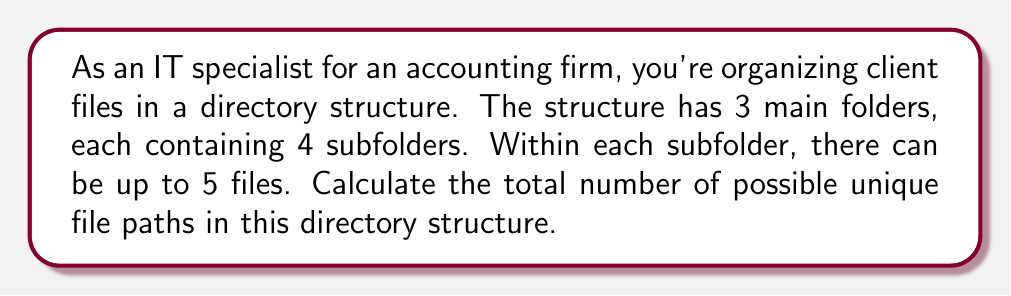Solve this math problem. Let's break this down step-by-step:

1) First, we need to understand what constitutes a file path. In this case, a file path consists of:
   - A main folder
   - A subfolder within that main folder
   - A file within that subfolder

2) Now, let's count the possibilities for each component:
   - There are 3 main folders
   - Each main folder has 4 subfolders
   - Each subfolder can contain up to 5 files

3) To calculate the total number of possible file paths, we use the multiplication principle of counting. This principle states that if we have $m$ ways of doing something and $n$ ways of doing another thing, then there are $m \times n$ ways of doing both things.

4) In this case:
   - We have 3 choices for the main folder
   - For each main folder, we have 4 choices of subfolder
   - For each subfolder, we have 5 choices of file

5) Therefore, the total number of possible file paths is:

   $$ 3 \times 4 \times 5 = 60 $$

This calculation gives us the maximum number of unique file paths, assuming each subfolder contains the maximum of 5 files.
Answer: 60 